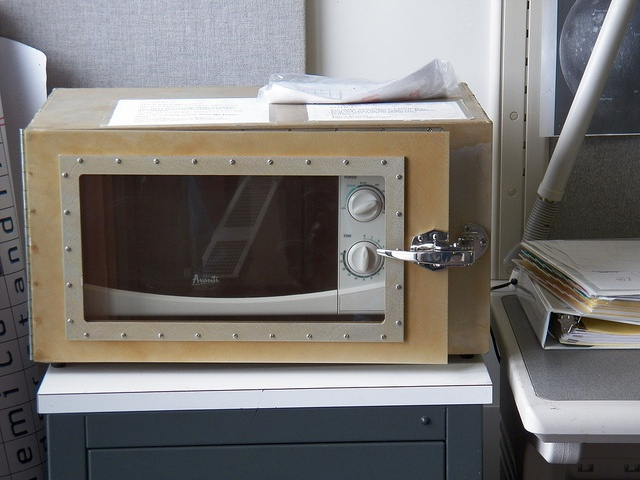Describe the objects in this image and their specific colors. I can see microwave in gray, black, darkgray, tan, and lightgray tones, book in gray, darkgray, and black tones, book in gray, black, darkgray, and tan tones, and book in gray, darkgray, lightgray, and black tones in this image. 